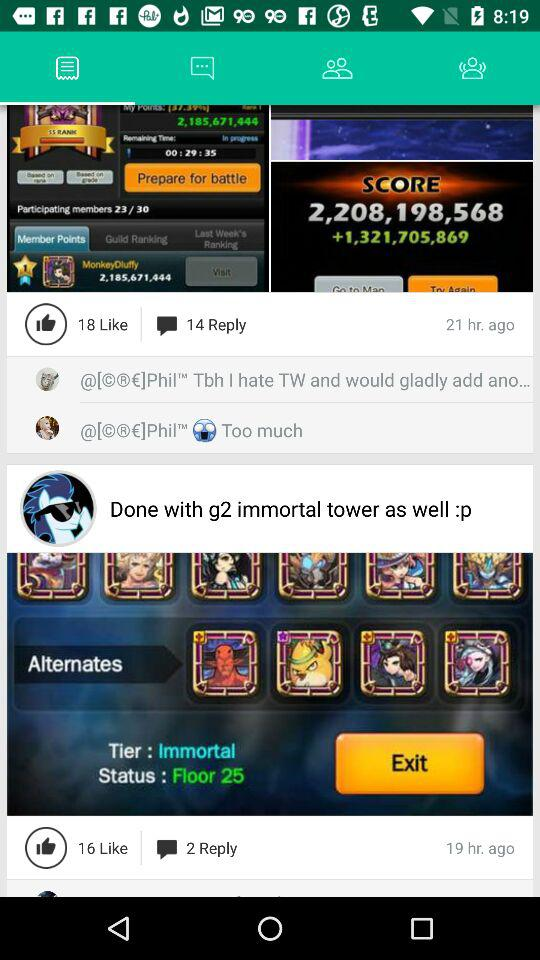What is the number of maximum like?
When the provided information is insufficient, respond with <no answer>. <no answer> 